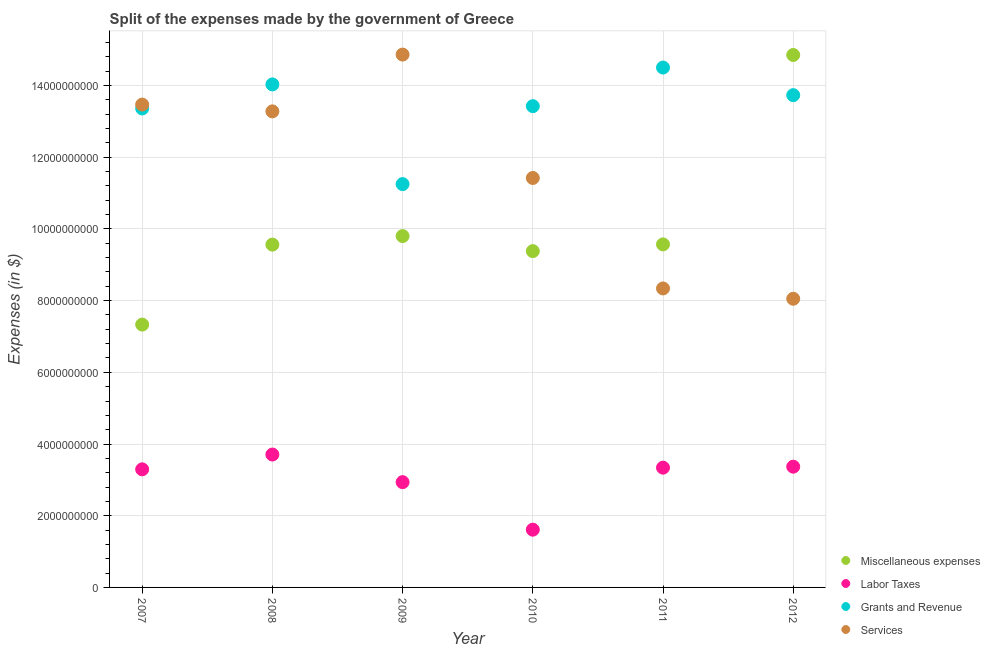What is the amount spent on labor taxes in 2011?
Offer a very short reply. 3.34e+09. Across all years, what is the maximum amount spent on grants and revenue?
Your answer should be compact. 1.45e+1. Across all years, what is the minimum amount spent on services?
Give a very brief answer. 8.05e+09. In which year was the amount spent on grants and revenue minimum?
Your answer should be compact. 2009. What is the total amount spent on labor taxes in the graph?
Ensure brevity in your answer.  1.83e+1. What is the difference between the amount spent on miscellaneous expenses in 2007 and that in 2012?
Provide a succinct answer. -7.52e+09. What is the difference between the amount spent on services in 2007 and the amount spent on labor taxes in 2012?
Ensure brevity in your answer.  1.01e+1. What is the average amount spent on miscellaneous expenses per year?
Give a very brief answer. 1.01e+1. In the year 2008, what is the difference between the amount spent on services and amount spent on miscellaneous expenses?
Your response must be concise. 3.72e+09. In how many years, is the amount spent on labor taxes greater than 10400000000 $?
Provide a succinct answer. 0. What is the ratio of the amount spent on services in 2010 to that in 2011?
Your answer should be compact. 1.37. What is the difference between the highest and the second highest amount spent on services?
Provide a short and direct response. 1.40e+09. What is the difference between the highest and the lowest amount spent on grants and revenue?
Provide a succinct answer. 3.25e+09. Is it the case that in every year, the sum of the amount spent on services and amount spent on labor taxes is greater than the sum of amount spent on grants and revenue and amount spent on miscellaneous expenses?
Offer a very short reply. No. Is it the case that in every year, the sum of the amount spent on miscellaneous expenses and amount spent on labor taxes is greater than the amount spent on grants and revenue?
Offer a very short reply. No. Does the amount spent on services monotonically increase over the years?
Your answer should be compact. No. Is the amount spent on services strictly greater than the amount spent on miscellaneous expenses over the years?
Offer a very short reply. No. How are the legend labels stacked?
Your answer should be very brief. Vertical. What is the title of the graph?
Provide a succinct answer. Split of the expenses made by the government of Greece. What is the label or title of the Y-axis?
Provide a short and direct response. Expenses (in $). What is the Expenses (in $) of Miscellaneous expenses in 2007?
Provide a short and direct response. 7.33e+09. What is the Expenses (in $) in Labor Taxes in 2007?
Give a very brief answer. 3.29e+09. What is the Expenses (in $) of Grants and Revenue in 2007?
Provide a succinct answer. 1.34e+1. What is the Expenses (in $) in Services in 2007?
Make the answer very short. 1.35e+1. What is the Expenses (in $) in Miscellaneous expenses in 2008?
Make the answer very short. 9.56e+09. What is the Expenses (in $) of Labor Taxes in 2008?
Make the answer very short. 3.71e+09. What is the Expenses (in $) in Grants and Revenue in 2008?
Give a very brief answer. 1.40e+1. What is the Expenses (in $) in Services in 2008?
Offer a very short reply. 1.33e+1. What is the Expenses (in $) of Miscellaneous expenses in 2009?
Your answer should be compact. 9.80e+09. What is the Expenses (in $) in Labor Taxes in 2009?
Ensure brevity in your answer.  2.94e+09. What is the Expenses (in $) of Grants and Revenue in 2009?
Keep it short and to the point. 1.13e+1. What is the Expenses (in $) in Services in 2009?
Make the answer very short. 1.49e+1. What is the Expenses (in $) in Miscellaneous expenses in 2010?
Offer a terse response. 9.38e+09. What is the Expenses (in $) in Labor Taxes in 2010?
Your response must be concise. 1.61e+09. What is the Expenses (in $) in Grants and Revenue in 2010?
Your response must be concise. 1.34e+1. What is the Expenses (in $) in Services in 2010?
Offer a terse response. 1.14e+1. What is the Expenses (in $) of Miscellaneous expenses in 2011?
Provide a short and direct response. 9.57e+09. What is the Expenses (in $) of Labor Taxes in 2011?
Your response must be concise. 3.34e+09. What is the Expenses (in $) in Grants and Revenue in 2011?
Your response must be concise. 1.45e+1. What is the Expenses (in $) in Services in 2011?
Your answer should be compact. 8.34e+09. What is the Expenses (in $) in Miscellaneous expenses in 2012?
Ensure brevity in your answer.  1.49e+1. What is the Expenses (in $) of Labor Taxes in 2012?
Make the answer very short. 3.37e+09. What is the Expenses (in $) of Grants and Revenue in 2012?
Make the answer very short. 1.37e+1. What is the Expenses (in $) in Services in 2012?
Offer a very short reply. 8.05e+09. Across all years, what is the maximum Expenses (in $) of Miscellaneous expenses?
Ensure brevity in your answer.  1.49e+1. Across all years, what is the maximum Expenses (in $) in Labor Taxes?
Provide a succinct answer. 3.71e+09. Across all years, what is the maximum Expenses (in $) in Grants and Revenue?
Keep it short and to the point. 1.45e+1. Across all years, what is the maximum Expenses (in $) in Services?
Offer a very short reply. 1.49e+1. Across all years, what is the minimum Expenses (in $) in Miscellaneous expenses?
Give a very brief answer. 7.33e+09. Across all years, what is the minimum Expenses (in $) of Labor Taxes?
Give a very brief answer. 1.61e+09. Across all years, what is the minimum Expenses (in $) of Grants and Revenue?
Provide a short and direct response. 1.13e+1. Across all years, what is the minimum Expenses (in $) of Services?
Give a very brief answer. 8.05e+09. What is the total Expenses (in $) in Miscellaneous expenses in the graph?
Ensure brevity in your answer.  6.05e+1. What is the total Expenses (in $) of Labor Taxes in the graph?
Make the answer very short. 1.83e+1. What is the total Expenses (in $) in Grants and Revenue in the graph?
Offer a terse response. 8.03e+1. What is the total Expenses (in $) in Services in the graph?
Keep it short and to the point. 6.94e+1. What is the difference between the Expenses (in $) of Miscellaneous expenses in 2007 and that in 2008?
Your response must be concise. -2.23e+09. What is the difference between the Expenses (in $) of Labor Taxes in 2007 and that in 2008?
Give a very brief answer. -4.13e+08. What is the difference between the Expenses (in $) of Grants and Revenue in 2007 and that in 2008?
Provide a short and direct response. -6.71e+08. What is the difference between the Expenses (in $) of Services in 2007 and that in 2008?
Offer a very short reply. 1.89e+08. What is the difference between the Expenses (in $) in Miscellaneous expenses in 2007 and that in 2009?
Your answer should be compact. -2.47e+09. What is the difference between the Expenses (in $) in Labor Taxes in 2007 and that in 2009?
Offer a very short reply. 3.57e+08. What is the difference between the Expenses (in $) of Grants and Revenue in 2007 and that in 2009?
Provide a short and direct response. 2.11e+09. What is the difference between the Expenses (in $) of Services in 2007 and that in 2009?
Your answer should be very brief. -1.40e+09. What is the difference between the Expenses (in $) of Miscellaneous expenses in 2007 and that in 2010?
Offer a terse response. -2.05e+09. What is the difference between the Expenses (in $) in Labor Taxes in 2007 and that in 2010?
Give a very brief answer. 1.68e+09. What is the difference between the Expenses (in $) of Grants and Revenue in 2007 and that in 2010?
Offer a very short reply. -6.40e+07. What is the difference between the Expenses (in $) in Services in 2007 and that in 2010?
Keep it short and to the point. 2.05e+09. What is the difference between the Expenses (in $) in Miscellaneous expenses in 2007 and that in 2011?
Provide a succinct answer. -2.24e+09. What is the difference between the Expenses (in $) in Labor Taxes in 2007 and that in 2011?
Offer a very short reply. -4.70e+07. What is the difference between the Expenses (in $) of Grants and Revenue in 2007 and that in 2011?
Provide a succinct answer. -1.14e+09. What is the difference between the Expenses (in $) of Services in 2007 and that in 2011?
Offer a very short reply. 5.13e+09. What is the difference between the Expenses (in $) in Miscellaneous expenses in 2007 and that in 2012?
Make the answer very short. -7.52e+09. What is the difference between the Expenses (in $) of Labor Taxes in 2007 and that in 2012?
Make the answer very short. -7.40e+07. What is the difference between the Expenses (in $) of Grants and Revenue in 2007 and that in 2012?
Ensure brevity in your answer.  -3.71e+08. What is the difference between the Expenses (in $) of Services in 2007 and that in 2012?
Your response must be concise. 5.42e+09. What is the difference between the Expenses (in $) of Miscellaneous expenses in 2008 and that in 2009?
Keep it short and to the point. -2.38e+08. What is the difference between the Expenses (in $) of Labor Taxes in 2008 and that in 2009?
Your response must be concise. 7.70e+08. What is the difference between the Expenses (in $) of Grants and Revenue in 2008 and that in 2009?
Make the answer very short. 2.78e+09. What is the difference between the Expenses (in $) of Services in 2008 and that in 2009?
Your answer should be compact. -1.58e+09. What is the difference between the Expenses (in $) of Miscellaneous expenses in 2008 and that in 2010?
Your answer should be compact. 1.82e+08. What is the difference between the Expenses (in $) of Labor Taxes in 2008 and that in 2010?
Your response must be concise. 2.10e+09. What is the difference between the Expenses (in $) in Grants and Revenue in 2008 and that in 2010?
Your response must be concise. 6.07e+08. What is the difference between the Expenses (in $) of Services in 2008 and that in 2010?
Provide a succinct answer. 1.86e+09. What is the difference between the Expenses (in $) of Miscellaneous expenses in 2008 and that in 2011?
Give a very brief answer. -6.00e+06. What is the difference between the Expenses (in $) in Labor Taxes in 2008 and that in 2011?
Your answer should be compact. 3.66e+08. What is the difference between the Expenses (in $) of Grants and Revenue in 2008 and that in 2011?
Make the answer very short. -4.70e+08. What is the difference between the Expenses (in $) in Services in 2008 and that in 2011?
Your response must be concise. 4.94e+09. What is the difference between the Expenses (in $) in Miscellaneous expenses in 2008 and that in 2012?
Offer a very short reply. -5.29e+09. What is the difference between the Expenses (in $) of Labor Taxes in 2008 and that in 2012?
Provide a short and direct response. 3.39e+08. What is the difference between the Expenses (in $) of Grants and Revenue in 2008 and that in 2012?
Your response must be concise. 3.00e+08. What is the difference between the Expenses (in $) in Services in 2008 and that in 2012?
Give a very brief answer. 5.23e+09. What is the difference between the Expenses (in $) in Miscellaneous expenses in 2009 and that in 2010?
Give a very brief answer. 4.20e+08. What is the difference between the Expenses (in $) of Labor Taxes in 2009 and that in 2010?
Offer a very short reply. 1.33e+09. What is the difference between the Expenses (in $) of Grants and Revenue in 2009 and that in 2010?
Keep it short and to the point. -2.17e+09. What is the difference between the Expenses (in $) in Services in 2009 and that in 2010?
Offer a terse response. 3.44e+09. What is the difference between the Expenses (in $) in Miscellaneous expenses in 2009 and that in 2011?
Ensure brevity in your answer.  2.32e+08. What is the difference between the Expenses (in $) of Labor Taxes in 2009 and that in 2011?
Make the answer very short. -4.04e+08. What is the difference between the Expenses (in $) of Grants and Revenue in 2009 and that in 2011?
Offer a terse response. -3.25e+09. What is the difference between the Expenses (in $) of Services in 2009 and that in 2011?
Provide a short and direct response. 6.52e+09. What is the difference between the Expenses (in $) in Miscellaneous expenses in 2009 and that in 2012?
Provide a short and direct response. -5.05e+09. What is the difference between the Expenses (in $) of Labor Taxes in 2009 and that in 2012?
Provide a succinct answer. -4.31e+08. What is the difference between the Expenses (in $) in Grants and Revenue in 2009 and that in 2012?
Keep it short and to the point. -2.48e+09. What is the difference between the Expenses (in $) in Services in 2009 and that in 2012?
Offer a terse response. 6.81e+09. What is the difference between the Expenses (in $) in Miscellaneous expenses in 2010 and that in 2011?
Your response must be concise. -1.88e+08. What is the difference between the Expenses (in $) in Labor Taxes in 2010 and that in 2011?
Your answer should be very brief. -1.73e+09. What is the difference between the Expenses (in $) of Grants and Revenue in 2010 and that in 2011?
Provide a short and direct response. -1.08e+09. What is the difference between the Expenses (in $) of Services in 2010 and that in 2011?
Your response must be concise. 3.08e+09. What is the difference between the Expenses (in $) of Miscellaneous expenses in 2010 and that in 2012?
Ensure brevity in your answer.  -5.47e+09. What is the difference between the Expenses (in $) in Labor Taxes in 2010 and that in 2012?
Your response must be concise. -1.76e+09. What is the difference between the Expenses (in $) of Grants and Revenue in 2010 and that in 2012?
Your response must be concise. -3.07e+08. What is the difference between the Expenses (in $) of Services in 2010 and that in 2012?
Ensure brevity in your answer.  3.37e+09. What is the difference between the Expenses (in $) of Miscellaneous expenses in 2011 and that in 2012?
Your answer should be compact. -5.28e+09. What is the difference between the Expenses (in $) in Labor Taxes in 2011 and that in 2012?
Ensure brevity in your answer.  -2.70e+07. What is the difference between the Expenses (in $) of Grants and Revenue in 2011 and that in 2012?
Offer a very short reply. 7.70e+08. What is the difference between the Expenses (in $) in Services in 2011 and that in 2012?
Provide a succinct answer. 2.87e+08. What is the difference between the Expenses (in $) of Miscellaneous expenses in 2007 and the Expenses (in $) of Labor Taxes in 2008?
Keep it short and to the point. 3.62e+09. What is the difference between the Expenses (in $) in Miscellaneous expenses in 2007 and the Expenses (in $) in Grants and Revenue in 2008?
Offer a terse response. -6.70e+09. What is the difference between the Expenses (in $) of Miscellaneous expenses in 2007 and the Expenses (in $) of Services in 2008?
Provide a short and direct response. -5.95e+09. What is the difference between the Expenses (in $) in Labor Taxes in 2007 and the Expenses (in $) in Grants and Revenue in 2008?
Your answer should be very brief. -1.07e+1. What is the difference between the Expenses (in $) in Labor Taxes in 2007 and the Expenses (in $) in Services in 2008?
Your answer should be very brief. -9.99e+09. What is the difference between the Expenses (in $) in Grants and Revenue in 2007 and the Expenses (in $) in Services in 2008?
Ensure brevity in your answer.  8.10e+07. What is the difference between the Expenses (in $) of Miscellaneous expenses in 2007 and the Expenses (in $) of Labor Taxes in 2009?
Your response must be concise. 4.40e+09. What is the difference between the Expenses (in $) of Miscellaneous expenses in 2007 and the Expenses (in $) of Grants and Revenue in 2009?
Provide a succinct answer. -3.92e+09. What is the difference between the Expenses (in $) in Miscellaneous expenses in 2007 and the Expenses (in $) in Services in 2009?
Provide a succinct answer. -7.53e+09. What is the difference between the Expenses (in $) in Labor Taxes in 2007 and the Expenses (in $) in Grants and Revenue in 2009?
Make the answer very short. -7.96e+09. What is the difference between the Expenses (in $) in Labor Taxes in 2007 and the Expenses (in $) in Services in 2009?
Ensure brevity in your answer.  -1.16e+1. What is the difference between the Expenses (in $) of Grants and Revenue in 2007 and the Expenses (in $) of Services in 2009?
Make the answer very short. -1.50e+09. What is the difference between the Expenses (in $) of Miscellaneous expenses in 2007 and the Expenses (in $) of Labor Taxes in 2010?
Provide a short and direct response. 5.72e+09. What is the difference between the Expenses (in $) of Miscellaneous expenses in 2007 and the Expenses (in $) of Grants and Revenue in 2010?
Give a very brief answer. -6.09e+09. What is the difference between the Expenses (in $) of Miscellaneous expenses in 2007 and the Expenses (in $) of Services in 2010?
Your response must be concise. -4.09e+09. What is the difference between the Expenses (in $) of Labor Taxes in 2007 and the Expenses (in $) of Grants and Revenue in 2010?
Give a very brief answer. -1.01e+1. What is the difference between the Expenses (in $) in Labor Taxes in 2007 and the Expenses (in $) in Services in 2010?
Keep it short and to the point. -8.13e+09. What is the difference between the Expenses (in $) of Grants and Revenue in 2007 and the Expenses (in $) of Services in 2010?
Offer a terse response. 1.94e+09. What is the difference between the Expenses (in $) of Miscellaneous expenses in 2007 and the Expenses (in $) of Labor Taxes in 2011?
Provide a succinct answer. 3.99e+09. What is the difference between the Expenses (in $) in Miscellaneous expenses in 2007 and the Expenses (in $) in Grants and Revenue in 2011?
Ensure brevity in your answer.  -7.17e+09. What is the difference between the Expenses (in $) of Miscellaneous expenses in 2007 and the Expenses (in $) of Services in 2011?
Offer a terse response. -1.01e+09. What is the difference between the Expenses (in $) in Labor Taxes in 2007 and the Expenses (in $) in Grants and Revenue in 2011?
Ensure brevity in your answer.  -1.12e+1. What is the difference between the Expenses (in $) in Labor Taxes in 2007 and the Expenses (in $) in Services in 2011?
Keep it short and to the point. -5.05e+09. What is the difference between the Expenses (in $) of Grants and Revenue in 2007 and the Expenses (in $) of Services in 2011?
Your answer should be compact. 5.02e+09. What is the difference between the Expenses (in $) of Miscellaneous expenses in 2007 and the Expenses (in $) of Labor Taxes in 2012?
Your answer should be compact. 3.96e+09. What is the difference between the Expenses (in $) in Miscellaneous expenses in 2007 and the Expenses (in $) in Grants and Revenue in 2012?
Keep it short and to the point. -6.40e+09. What is the difference between the Expenses (in $) of Miscellaneous expenses in 2007 and the Expenses (in $) of Services in 2012?
Offer a terse response. -7.21e+08. What is the difference between the Expenses (in $) of Labor Taxes in 2007 and the Expenses (in $) of Grants and Revenue in 2012?
Ensure brevity in your answer.  -1.04e+1. What is the difference between the Expenses (in $) in Labor Taxes in 2007 and the Expenses (in $) in Services in 2012?
Your response must be concise. -4.76e+09. What is the difference between the Expenses (in $) of Grants and Revenue in 2007 and the Expenses (in $) of Services in 2012?
Provide a succinct answer. 5.31e+09. What is the difference between the Expenses (in $) of Miscellaneous expenses in 2008 and the Expenses (in $) of Labor Taxes in 2009?
Offer a terse response. 6.63e+09. What is the difference between the Expenses (in $) in Miscellaneous expenses in 2008 and the Expenses (in $) in Grants and Revenue in 2009?
Ensure brevity in your answer.  -1.69e+09. What is the difference between the Expenses (in $) of Miscellaneous expenses in 2008 and the Expenses (in $) of Services in 2009?
Your answer should be very brief. -5.30e+09. What is the difference between the Expenses (in $) of Labor Taxes in 2008 and the Expenses (in $) of Grants and Revenue in 2009?
Provide a short and direct response. -7.54e+09. What is the difference between the Expenses (in $) in Labor Taxes in 2008 and the Expenses (in $) in Services in 2009?
Ensure brevity in your answer.  -1.12e+1. What is the difference between the Expenses (in $) of Grants and Revenue in 2008 and the Expenses (in $) of Services in 2009?
Offer a terse response. -8.32e+08. What is the difference between the Expenses (in $) of Miscellaneous expenses in 2008 and the Expenses (in $) of Labor Taxes in 2010?
Your answer should be compact. 7.95e+09. What is the difference between the Expenses (in $) of Miscellaneous expenses in 2008 and the Expenses (in $) of Grants and Revenue in 2010?
Give a very brief answer. -3.86e+09. What is the difference between the Expenses (in $) of Miscellaneous expenses in 2008 and the Expenses (in $) of Services in 2010?
Give a very brief answer. -1.86e+09. What is the difference between the Expenses (in $) in Labor Taxes in 2008 and the Expenses (in $) in Grants and Revenue in 2010?
Give a very brief answer. -9.72e+09. What is the difference between the Expenses (in $) of Labor Taxes in 2008 and the Expenses (in $) of Services in 2010?
Keep it short and to the point. -7.72e+09. What is the difference between the Expenses (in $) in Grants and Revenue in 2008 and the Expenses (in $) in Services in 2010?
Offer a terse response. 2.61e+09. What is the difference between the Expenses (in $) of Miscellaneous expenses in 2008 and the Expenses (in $) of Labor Taxes in 2011?
Offer a terse response. 6.22e+09. What is the difference between the Expenses (in $) of Miscellaneous expenses in 2008 and the Expenses (in $) of Grants and Revenue in 2011?
Give a very brief answer. -4.94e+09. What is the difference between the Expenses (in $) in Miscellaneous expenses in 2008 and the Expenses (in $) in Services in 2011?
Provide a succinct answer. 1.22e+09. What is the difference between the Expenses (in $) in Labor Taxes in 2008 and the Expenses (in $) in Grants and Revenue in 2011?
Keep it short and to the point. -1.08e+1. What is the difference between the Expenses (in $) in Labor Taxes in 2008 and the Expenses (in $) in Services in 2011?
Offer a terse response. -4.63e+09. What is the difference between the Expenses (in $) in Grants and Revenue in 2008 and the Expenses (in $) in Services in 2011?
Your answer should be compact. 5.69e+09. What is the difference between the Expenses (in $) of Miscellaneous expenses in 2008 and the Expenses (in $) of Labor Taxes in 2012?
Your answer should be compact. 6.20e+09. What is the difference between the Expenses (in $) of Miscellaneous expenses in 2008 and the Expenses (in $) of Grants and Revenue in 2012?
Ensure brevity in your answer.  -4.17e+09. What is the difference between the Expenses (in $) of Miscellaneous expenses in 2008 and the Expenses (in $) of Services in 2012?
Provide a succinct answer. 1.51e+09. What is the difference between the Expenses (in $) in Labor Taxes in 2008 and the Expenses (in $) in Grants and Revenue in 2012?
Your answer should be very brief. -1.00e+1. What is the difference between the Expenses (in $) in Labor Taxes in 2008 and the Expenses (in $) in Services in 2012?
Make the answer very short. -4.35e+09. What is the difference between the Expenses (in $) in Grants and Revenue in 2008 and the Expenses (in $) in Services in 2012?
Make the answer very short. 5.98e+09. What is the difference between the Expenses (in $) in Miscellaneous expenses in 2009 and the Expenses (in $) in Labor Taxes in 2010?
Your answer should be compact. 8.19e+09. What is the difference between the Expenses (in $) of Miscellaneous expenses in 2009 and the Expenses (in $) of Grants and Revenue in 2010?
Give a very brief answer. -3.62e+09. What is the difference between the Expenses (in $) in Miscellaneous expenses in 2009 and the Expenses (in $) in Services in 2010?
Provide a short and direct response. -1.62e+09. What is the difference between the Expenses (in $) of Labor Taxes in 2009 and the Expenses (in $) of Grants and Revenue in 2010?
Your response must be concise. -1.05e+1. What is the difference between the Expenses (in $) in Labor Taxes in 2009 and the Expenses (in $) in Services in 2010?
Your answer should be very brief. -8.48e+09. What is the difference between the Expenses (in $) in Grants and Revenue in 2009 and the Expenses (in $) in Services in 2010?
Give a very brief answer. -1.71e+08. What is the difference between the Expenses (in $) in Miscellaneous expenses in 2009 and the Expenses (in $) in Labor Taxes in 2011?
Offer a terse response. 6.46e+09. What is the difference between the Expenses (in $) in Miscellaneous expenses in 2009 and the Expenses (in $) in Grants and Revenue in 2011?
Give a very brief answer. -4.70e+09. What is the difference between the Expenses (in $) in Miscellaneous expenses in 2009 and the Expenses (in $) in Services in 2011?
Your response must be concise. 1.46e+09. What is the difference between the Expenses (in $) in Labor Taxes in 2009 and the Expenses (in $) in Grants and Revenue in 2011?
Your answer should be compact. -1.16e+1. What is the difference between the Expenses (in $) of Labor Taxes in 2009 and the Expenses (in $) of Services in 2011?
Offer a terse response. -5.40e+09. What is the difference between the Expenses (in $) in Grants and Revenue in 2009 and the Expenses (in $) in Services in 2011?
Give a very brief answer. 2.91e+09. What is the difference between the Expenses (in $) of Miscellaneous expenses in 2009 and the Expenses (in $) of Labor Taxes in 2012?
Offer a very short reply. 6.43e+09. What is the difference between the Expenses (in $) in Miscellaneous expenses in 2009 and the Expenses (in $) in Grants and Revenue in 2012?
Offer a very short reply. -3.93e+09. What is the difference between the Expenses (in $) in Miscellaneous expenses in 2009 and the Expenses (in $) in Services in 2012?
Your response must be concise. 1.75e+09. What is the difference between the Expenses (in $) of Labor Taxes in 2009 and the Expenses (in $) of Grants and Revenue in 2012?
Give a very brief answer. -1.08e+1. What is the difference between the Expenses (in $) in Labor Taxes in 2009 and the Expenses (in $) in Services in 2012?
Your response must be concise. -5.12e+09. What is the difference between the Expenses (in $) in Grants and Revenue in 2009 and the Expenses (in $) in Services in 2012?
Keep it short and to the point. 3.20e+09. What is the difference between the Expenses (in $) in Miscellaneous expenses in 2010 and the Expenses (in $) in Labor Taxes in 2011?
Give a very brief answer. 6.04e+09. What is the difference between the Expenses (in $) in Miscellaneous expenses in 2010 and the Expenses (in $) in Grants and Revenue in 2011?
Give a very brief answer. -5.12e+09. What is the difference between the Expenses (in $) of Miscellaneous expenses in 2010 and the Expenses (in $) of Services in 2011?
Keep it short and to the point. 1.04e+09. What is the difference between the Expenses (in $) of Labor Taxes in 2010 and the Expenses (in $) of Grants and Revenue in 2011?
Make the answer very short. -1.29e+1. What is the difference between the Expenses (in $) in Labor Taxes in 2010 and the Expenses (in $) in Services in 2011?
Offer a very short reply. -6.73e+09. What is the difference between the Expenses (in $) of Grants and Revenue in 2010 and the Expenses (in $) of Services in 2011?
Give a very brief answer. 5.08e+09. What is the difference between the Expenses (in $) in Miscellaneous expenses in 2010 and the Expenses (in $) in Labor Taxes in 2012?
Give a very brief answer. 6.01e+09. What is the difference between the Expenses (in $) of Miscellaneous expenses in 2010 and the Expenses (in $) of Grants and Revenue in 2012?
Give a very brief answer. -4.35e+09. What is the difference between the Expenses (in $) of Miscellaneous expenses in 2010 and the Expenses (in $) of Services in 2012?
Provide a short and direct response. 1.33e+09. What is the difference between the Expenses (in $) in Labor Taxes in 2010 and the Expenses (in $) in Grants and Revenue in 2012?
Keep it short and to the point. -1.21e+1. What is the difference between the Expenses (in $) in Labor Taxes in 2010 and the Expenses (in $) in Services in 2012?
Offer a terse response. -6.44e+09. What is the difference between the Expenses (in $) of Grants and Revenue in 2010 and the Expenses (in $) of Services in 2012?
Make the answer very short. 5.37e+09. What is the difference between the Expenses (in $) of Miscellaneous expenses in 2011 and the Expenses (in $) of Labor Taxes in 2012?
Offer a very short reply. 6.20e+09. What is the difference between the Expenses (in $) in Miscellaneous expenses in 2011 and the Expenses (in $) in Grants and Revenue in 2012?
Provide a succinct answer. -4.16e+09. What is the difference between the Expenses (in $) of Miscellaneous expenses in 2011 and the Expenses (in $) of Services in 2012?
Your response must be concise. 1.52e+09. What is the difference between the Expenses (in $) of Labor Taxes in 2011 and the Expenses (in $) of Grants and Revenue in 2012?
Keep it short and to the point. -1.04e+1. What is the difference between the Expenses (in $) of Labor Taxes in 2011 and the Expenses (in $) of Services in 2012?
Offer a very short reply. -4.71e+09. What is the difference between the Expenses (in $) of Grants and Revenue in 2011 and the Expenses (in $) of Services in 2012?
Provide a short and direct response. 6.45e+09. What is the average Expenses (in $) of Miscellaneous expenses per year?
Provide a short and direct response. 1.01e+1. What is the average Expenses (in $) of Labor Taxes per year?
Provide a succinct answer. 3.04e+09. What is the average Expenses (in $) of Grants and Revenue per year?
Offer a terse response. 1.34e+1. What is the average Expenses (in $) of Services per year?
Keep it short and to the point. 1.16e+1. In the year 2007, what is the difference between the Expenses (in $) in Miscellaneous expenses and Expenses (in $) in Labor Taxes?
Give a very brief answer. 4.04e+09. In the year 2007, what is the difference between the Expenses (in $) in Miscellaneous expenses and Expenses (in $) in Grants and Revenue?
Offer a very short reply. -6.03e+09. In the year 2007, what is the difference between the Expenses (in $) in Miscellaneous expenses and Expenses (in $) in Services?
Your response must be concise. -6.14e+09. In the year 2007, what is the difference between the Expenses (in $) in Labor Taxes and Expenses (in $) in Grants and Revenue?
Give a very brief answer. -1.01e+1. In the year 2007, what is the difference between the Expenses (in $) of Labor Taxes and Expenses (in $) of Services?
Give a very brief answer. -1.02e+1. In the year 2007, what is the difference between the Expenses (in $) in Grants and Revenue and Expenses (in $) in Services?
Your answer should be compact. -1.08e+08. In the year 2008, what is the difference between the Expenses (in $) in Miscellaneous expenses and Expenses (in $) in Labor Taxes?
Make the answer very short. 5.86e+09. In the year 2008, what is the difference between the Expenses (in $) of Miscellaneous expenses and Expenses (in $) of Grants and Revenue?
Give a very brief answer. -4.47e+09. In the year 2008, what is the difference between the Expenses (in $) in Miscellaneous expenses and Expenses (in $) in Services?
Your answer should be compact. -3.72e+09. In the year 2008, what is the difference between the Expenses (in $) in Labor Taxes and Expenses (in $) in Grants and Revenue?
Your answer should be very brief. -1.03e+1. In the year 2008, what is the difference between the Expenses (in $) in Labor Taxes and Expenses (in $) in Services?
Keep it short and to the point. -9.57e+09. In the year 2008, what is the difference between the Expenses (in $) of Grants and Revenue and Expenses (in $) of Services?
Offer a terse response. 7.52e+08. In the year 2009, what is the difference between the Expenses (in $) in Miscellaneous expenses and Expenses (in $) in Labor Taxes?
Keep it short and to the point. 6.86e+09. In the year 2009, what is the difference between the Expenses (in $) of Miscellaneous expenses and Expenses (in $) of Grants and Revenue?
Ensure brevity in your answer.  -1.45e+09. In the year 2009, what is the difference between the Expenses (in $) of Miscellaneous expenses and Expenses (in $) of Services?
Offer a terse response. -5.06e+09. In the year 2009, what is the difference between the Expenses (in $) of Labor Taxes and Expenses (in $) of Grants and Revenue?
Give a very brief answer. -8.31e+09. In the year 2009, what is the difference between the Expenses (in $) of Labor Taxes and Expenses (in $) of Services?
Ensure brevity in your answer.  -1.19e+1. In the year 2009, what is the difference between the Expenses (in $) of Grants and Revenue and Expenses (in $) of Services?
Provide a succinct answer. -3.61e+09. In the year 2010, what is the difference between the Expenses (in $) of Miscellaneous expenses and Expenses (in $) of Labor Taxes?
Offer a terse response. 7.77e+09. In the year 2010, what is the difference between the Expenses (in $) of Miscellaneous expenses and Expenses (in $) of Grants and Revenue?
Make the answer very short. -4.04e+09. In the year 2010, what is the difference between the Expenses (in $) of Miscellaneous expenses and Expenses (in $) of Services?
Keep it short and to the point. -2.04e+09. In the year 2010, what is the difference between the Expenses (in $) of Labor Taxes and Expenses (in $) of Grants and Revenue?
Offer a terse response. -1.18e+1. In the year 2010, what is the difference between the Expenses (in $) of Labor Taxes and Expenses (in $) of Services?
Ensure brevity in your answer.  -9.81e+09. In the year 2010, what is the difference between the Expenses (in $) in Grants and Revenue and Expenses (in $) in Services?
Give a very brief answer. 2.00e+09. In the year 2011, what is the difference between the Expenses (in $) of Miscellaneous expenses and Expenses (in $) of Labor Taxes?
Make the answer very short. 6.23e+09. In the year 2011, what is the difference between the Expenses (in $) in Miscellaneous expenses and Expenses (in $) in Grants and Revenue?
Provide a short and direct response. -4.93e+09. In the year 2011, what is the difference between the Expenses (in $) of Miscellaneous expenses and Expenses (in $) of Services?
Offer a terse response. 1.23e+09. In the year 2011, what is the difference between the Expenses (in $) of Labor Taxes and Expenses (in $) of Grants and Revenue?
Your answer should be very brief. -1.12e+1. In the year 2011, what is the difference between the Expenses (in $) in Labor Taxes and Expenses (in $) in Services?
Make the answer very short. -5.00e+09. In the year 2011, what is the difference between the Expenses (in $) of Grants and Revenue and Expenses (in $) of Services?
Offer a very short reply. 6.16e+09. In the year 2012, what is the difference between the Expenses (in $) of Miscellaneous expenses and Expenses (in $) of Labor Taxes?
Your answer should be very brief. 1.15e+1. In the year 2012, what is the difference between the Expenses (in $) of Miscellaneous expenses and Expenses (in $) of Grants and Revenue?
Give a very brief answer. 1.12e+09. In the year 2012, what is the difference between the Expenses (in $) of Miscellaneous expenses and Expenses (in $) of Services?
Your answer should be very brief. 6.80e+09. In the year 2012, what is the difference between the Expenses (in $) in Labor Taxes and Expenses (in $) in Grants and Revenue?
Offer a terse response. -1.04e+1. In the year 2012, what is the difference between the Expenses (in $) in Labor Taxes and Expenses (in $) in Services?
Provide a short and direct response. -4.68e+09. In the year 2012, what is the difference between the Expenses (in $) in Grants and Revenue and Expenses (in $) in Services?
Make the answer very short. 5.68e+09. What is the ratio of the Expenses (in $) of Miscellaneous expenses in 2007 to that in 2008?
Offer a terse response. 0.77. What is the ratio of the Expenses (in $) of Labor Taxes in 2007 to that in 2008?
Ensure brevity in your answer.  0.89. What is the ratio of the Expenses (in $) of Grants and Revenue in 2007 to that in 2008?
Give a very brief answer. 0.95. What is the ratio of the Expenses (in $) of Services in 2007 to that in 2008?
Provide a short and direct response. 1.01. What is the ratio of the Expenses (in $) of Miscellaneous expenses in 2007 to that in 2009?
Make the answer very short. 0.75. What is the ratio of the Expenses (in $) of Labor Taxes in 2007 to that in 2009?
Give a very brief answer. 1.12. What is the ratio of the Expenses (in $) in Grants and Revenue in 2007 to that in 2009?
Provide a succinct answer. 1.19. What is the ratio of the Expenses (in $) of Services in 2007 to that in 2009?
Your answer should be very brief. 0.91. What is the ratio of the Expenses (in $) of Miscellaneous expenses in 2007 to that in 2010?
Keep it short and to the point. 0.78. What is the ratio of the Expenses (in $) of Labor Taxes in 2007 to that in 2010?
Make the answer very short. 2.04. What is the ratio of the Expenses (in $) of Services in 2007 to that in 2010?
Give a very brief answer. 1.18. What is the ratio of the Expenses (in $) in Miscellaneous expenses in 2007 to that in 2011?
Offer a terse response. 0.77. What is the ratio of the Expenses (in $) in Labor Taxes in 2007 to that in 2011?
Make the answer very short. 0.99. What is the ratio of the Expenses (in $) of Grants and Revenue in 2007 to that in 2011?
Keep it short and to the point. 0.92. What is the ratio of the Expenses (in $) in Services in 2007 to that in 2011?
Offer a very short reply. 1.61. What is the ratio of the Expenses (in $) of Miscellaneous expenses in 2007 to that in 2012?
Make the answer very short. 0.49. What is the ratio of the Expenses (in $) in Labor Taxes in 2007 to that in 2012?
Offer a terse response. 0.98. What is the ratio of the Expenses (in $) of Services in 2007 to that in 2012?
Offer a very short reply. 1.67. What is the ratio of the Expenses (in $) of Miscellaneous expenses in 2008 to that in 2009?
Make the answer very short. 0.98. What is the ratio of the Expenses (in $) in Labor Taxes in 2008 to that in 2009?
Give a very brief answer. 1.26. What is the ratio of the Expenses (in $) in Grants and Revenue in 2008 to that in 2009?
Keep it short and to the point. 1.25. What is the ratio of the Expenses (in $) in Services in 2008 to that in 2009?
Provide a succinct answer. 0.89. What is the ratio of the Expenses (in $) of Miscellaneous expenses in 2008 to that in 2010?
Your answer should be very brief. 1.02. What is the ratio of the Expenses (in $) of Labor Taxes in 2008 to that in 2010?
Keep it short and to the point. 2.3. What is the ratio of the Expenses (in $) in Grants and Revenue in 2008 to that in 2010?
Keep it short and to the point. 1.05. What is the ratio of the Expenses (in $) in Services in 2008 to that in 2010?
Your answer should be compact. 1.16. What is the ratio of the Expenses (in $) in Miscellaneous expenses in 2008 to that in 2011?
Your answer should be very brief. 1. What is the ratio of the Expenses (in $) in Labor Taxes in 2008 to that in 2011?
Your response must be concise. 1.11. What is the ratio of the Expenses (in $) in Grants and Revenue in 2008 to that in 2011?
Offer a very short reply. 0.97. What is the ratio of the Expenses (in $) in Services in 2008 to that in 2011?
Your answer should be compact. 1.59. What is the ratio of the Expenses (in $) in Miscellaneous expenses in 2008 to that in 2012?
Provide a succinct answer. 0.64. What is the ratio of the Expenses (in $) in Labor Taxes in 2008 to that in 2012?
Offer a terse response. 1.1. What is the ratio of the Expenses (in $) of Grants and Revenue in 2008 to that in 2012?
Your answer should be compact. 1.02. What is the ratio of the Expenses (in $) in Services in 2008 to that in 2012?
Make the answer very short. 1.65. What is the ratio of the Expenses (in $) in Miscellaneous expenses in 2009 to that in 2010?
Offer a terse response. 1.04. What is the ratio of the Expenses (in $) of Labor Taxes in 2009 to that in 2010?
Ensure brevity in your answer.  1.82. What is the ratio of the Expenses (in $) of Grants and Revenue in 2009 to that in 2010?
Offer a terse response. 0.84. What is the ratio of the Expenses (in $) in Services in 2009 to that in 2010?
Give a very brief answer. 1.3. What is the ratio of the Expenses (in $) of Miscellaneous expenses in 2009 to that in 2011?
Give a very brief answer. 1.02. What is the ratio of the Expenses (in $) in Labor Taxes in 2009 to that in 2011?
Offer a terse response. 0.88. What is the ratio of the Expenses (in $) of Grants and Revenue in 2009 to that in 2011?
Make the answer very short. 0.78. What is the ratio of the Expenses (in $) of Services in 2009 to that in 2011?
Make the answer very short. 1.78. What is the ratio of the Expenses (in $) in Miscellaneous expenses in 2009 to that in 2012?
Your answer should be very brief. 0.66. What is the ratio of the Expenses (in $) in Labor Taxes in 2009 to that in 2012?
Keep it short and to the point. 0.87. What is the ratio of the Expenses (in $) in Grants and Revenue in 2009 to that in 2012?
Ensure brevity in your answer.  0.82. What is the ratio of the Expenses (in $) of Services in 2009 to that in 2012?
Ensure brevity in your answer.  1.85. What is the ratio of the Expenses (in $) of Miscellaneous expenses in 2010 to that in 2011?
Your answer should be very brief. 0.98. What is the ratio of the Expenses (in $) of Labor Taxes in 2010 to that in 2011?
Provide a succinct answer. 0.48. What is the ratio of the Expenses (in $) of Grants and Revenue in 2010 to that in 2011?
Offer a very short reply. 0.93. What is the ratio of the Expenses (in $) of Services in 2010 to that in 2011?
Offer a very short reply. 1.37. What is the ratio of the Expenses (in $) in Miscellaneous expenses in 2010 to that in 2012?
Offer a very short reply. 0.63. What is the ratio of the Expenses (in $) of Labor Taxes in 2010 to that in 2012?
Provide a short and direct response. 0.48. What is the ratio of the Expenses (in $) of Grants and Revenue in 2010 to that in 2012?
Your answer should be compact. 0.98. What is the ratio of the Expenses (in $) of Services in 2010 to that in 2012?
Offer a terse response. 1.42. What is the ratio of the Expenses (in $) of Miscellaneous expenses in 2011 to that in 2012?
Give a very brief answer. 0.64. What is the ratio of the Expenses (in $) of Labor Taxes in 2011 to that in 2012?
Provide a short and direct response. 0.99. What is the ratio of the Expenses (in $) of Grants and Revenue in 2011 to that in 2012?
Make the answer very short. 1.06. What is the ratio of the Expenses (in $) in Services in 2011 to that in 2012?
Ensure brevity in your answer.  1.04. What is the difference between the highest and the second highest Expenses (in $) in Miscellaneous expenses?
Your answer should be very brief. 5.05e+09. What is the difference between the highest and the second highest Expenses (in $) in Labor Taxes?
Provide a succinct answer. 3.39e+08. What is the difference between the highest and the second highest Expenses (in $) of Grants and Revenue?
Your answer should be very brief. 4.70e+08. What is the difference between the highest and the second highest Expenses (in $) of Services?
Offer a terse response. 1.40e+09. What is the difference between the highest and the lowest Expenses (in $) of Miscellaneous expenses?
Offer a very short reply. 7.52e+09. What is the difference between the highest and the lowest Expenses (in $) in Labor Taxes?
Make the answer very short. 2.10e+09. What is the difference between the highest and the lowest Expenses (in $) of Grants and Revenue?
Your answer should be very brief. 3.25e+09. What is the difference between the highest and the lowest Expenses (in $) in Services?
Ensure brevity in your answer.  6.81e+09. 